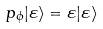<formula> <loc_0><loc_0><loc_500><loc_500>p _ { \phi } | \varepsilon \rangle = \varepsilon | \varepsilon \rangle</formula> 